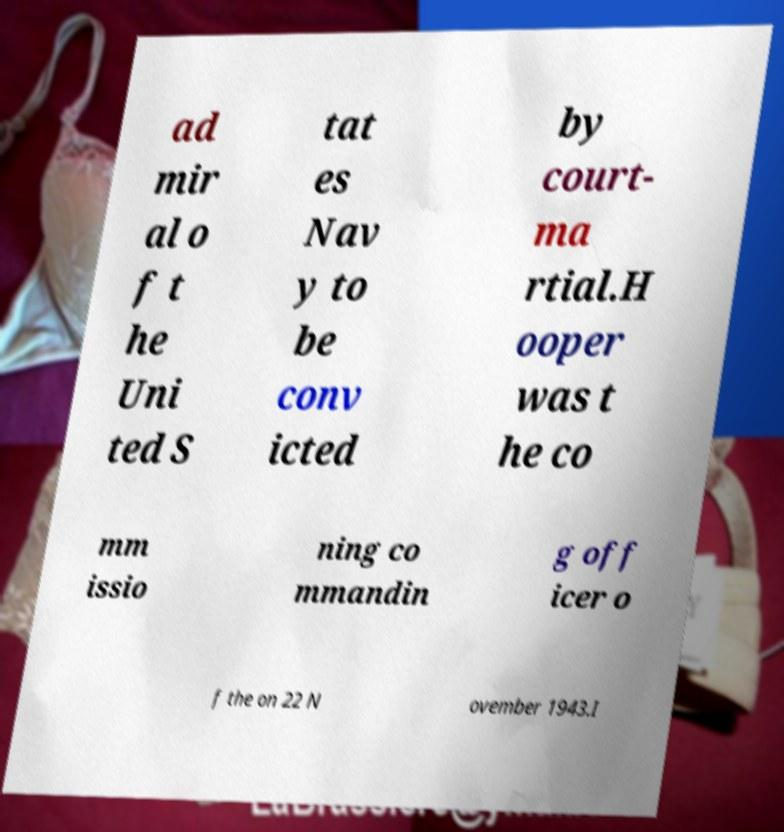Can you accurately transcribe the text from the provided image for me? ad mir al o f t he Uni ted S tat es Nav y to be conv icted by court- ma rtial.H ooper was t he co mm issio ning co mmandin g off icer o f the on 22 N ovember 1943.I 